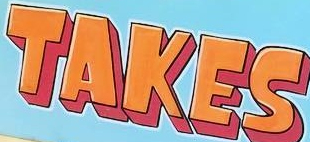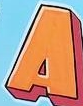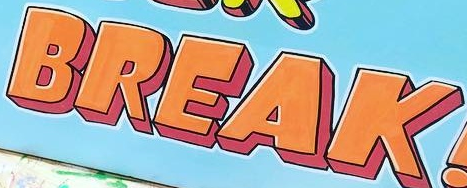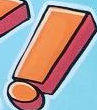Read the text from these images in sequence, separated by a semicolon. TAKES; A; BREAK; ! 